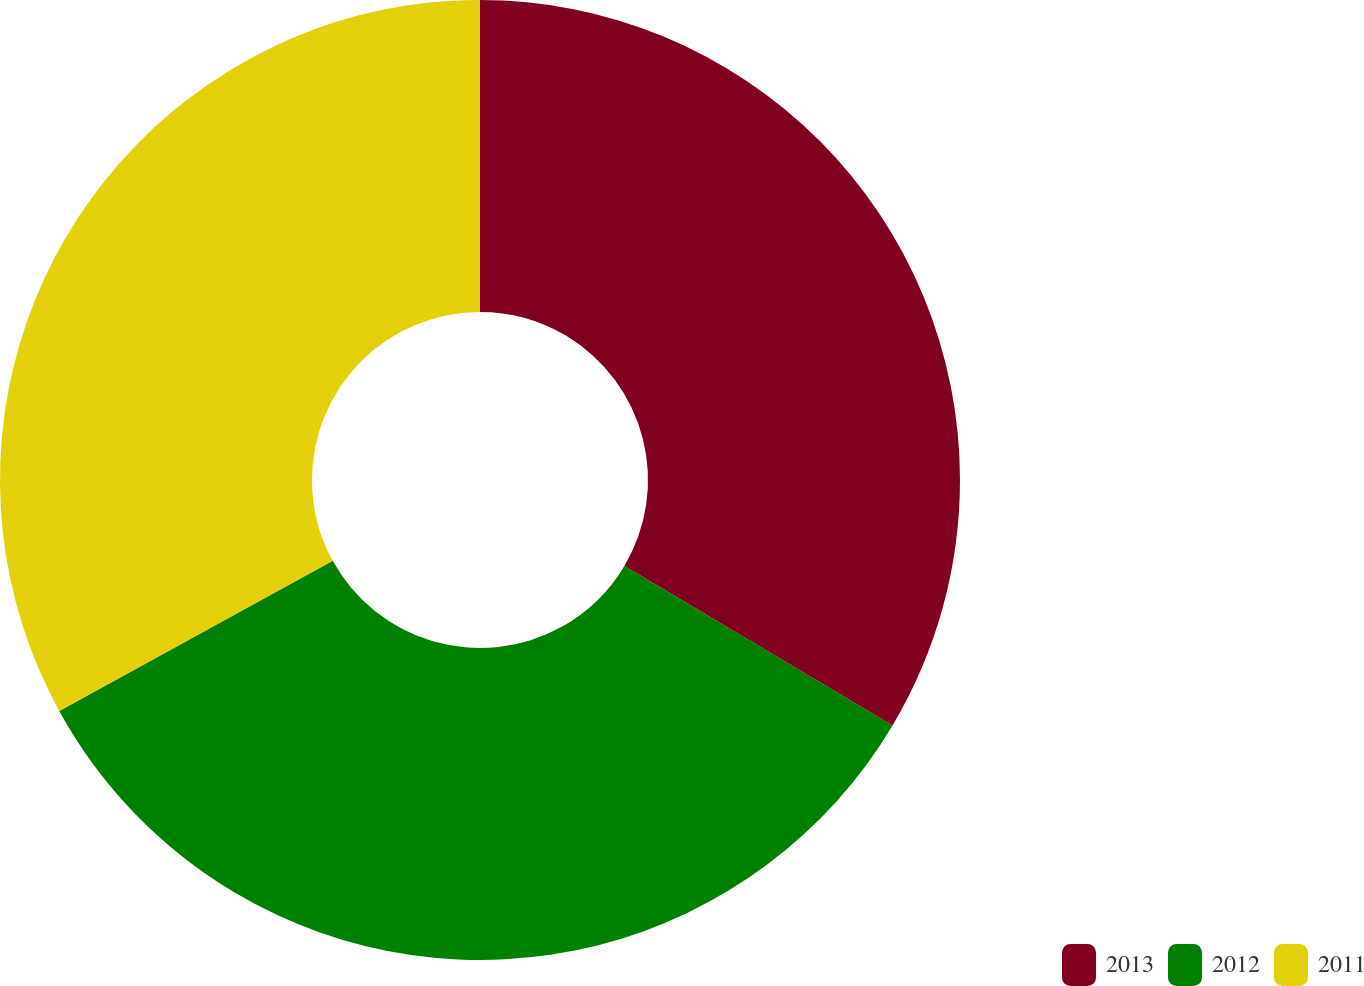Convert chart. <chart><loc_0><loc_0><loc_500><loc_500><pie_chart><fcel>2013<fcel>2012<fcel>2011<nl><fcel>33.54%<fcel>33.47%<fcel>32.99%<nl></chart> 